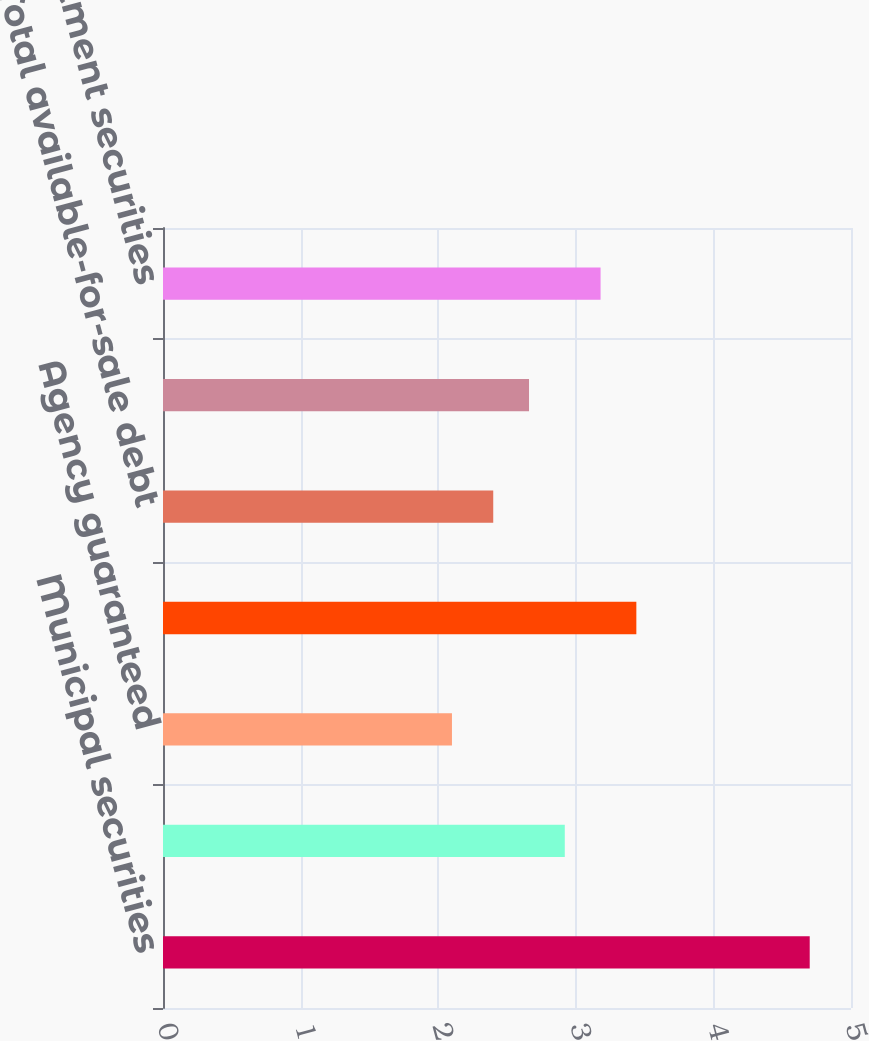Convert chart to OTSL. <chart><loc_0><loc_0><loc_500><loc_500><bar_chart><fcel>Municipal securities<fcel>Agency securities<fcel>Agency guaranteed<fcel>Small Business Administration<fcel>Total available-for-sale debt<fcel>Total available-for-sale<fcel>Total investment securities<nl><fcel>4.7<fcel>2.92<fcel>2.1<fcel>3.44<fcel>2.4<fcel>2.66<fcel>3.18<nl></chart> 